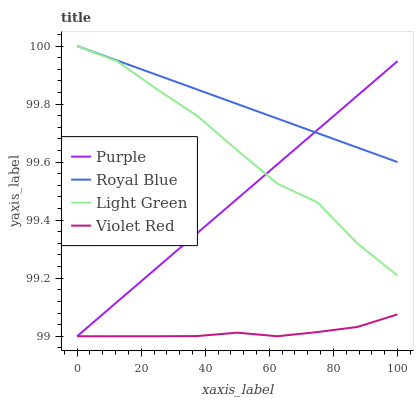Does Violet Red have the minimum area under the curve?
Answer yes or no. Yes. Does Royal Blue have the maximum area under the curve?
Answer yes or no. Yes. Does Royal Blue have the minimum area under the curve?
Answer yes or no. No. Does Violet Red have the maximum area under the curve?
Answer yes or no. No. Is Purple the smoothest?
Answer yes or no. Yes. Is Light Green the roughest?
Answer yes or no. Yes. Is Royal Blue the smoothest?
Answer yes or no. No. Is Royal Blue the roughest?
Answer yes or no. No. Does Royal Blue have the lowest value?
Answer yes or no. No. Does Light Green have the highest value?
Answer yes or no. Yes. Does Violet Red have the highest value?
Answer yes or no. No. Is Violet Red less than Royal Blue?
Answer yes or no. Yes. Is Light Green greater than Violet Red?
Answer yes or no. Yes. Does Light Green intersect Purple?
Answer yes or no. Yes. Is Light Green less than Purple?
Answer yes or no. No. Is Light Green greater than Purple?
Answer yes or no. No. Does Violet Red intersect Royal Blue?
Answer yes or no. No. 